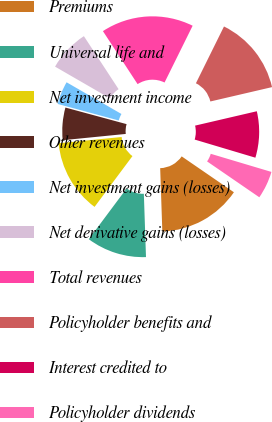Convert chart to OTSL. <chart><loc_0><loc_0><loc_500><loc_500><pie_chart><fcel>Premiums<fcel>Universal life and<fcel>Net investment income<fcel>Other revenues<fcel>Net investment gains (losses)<fcel>Net derivative gains (losses)<fcel>Total revenues<fcel>Policyholder benefits and<fcel>Interest credited to<fcel>Policyholder dividends<nl><fcel>14.88%<fcel>10.74%<fcel>13.22%<fcel>5.79%<fcel>4.13%<fcel>7.44%<fcel>16.53%<fcel>14.05%<fcel>8.26%<fcel>4.96%<nl></chart> 